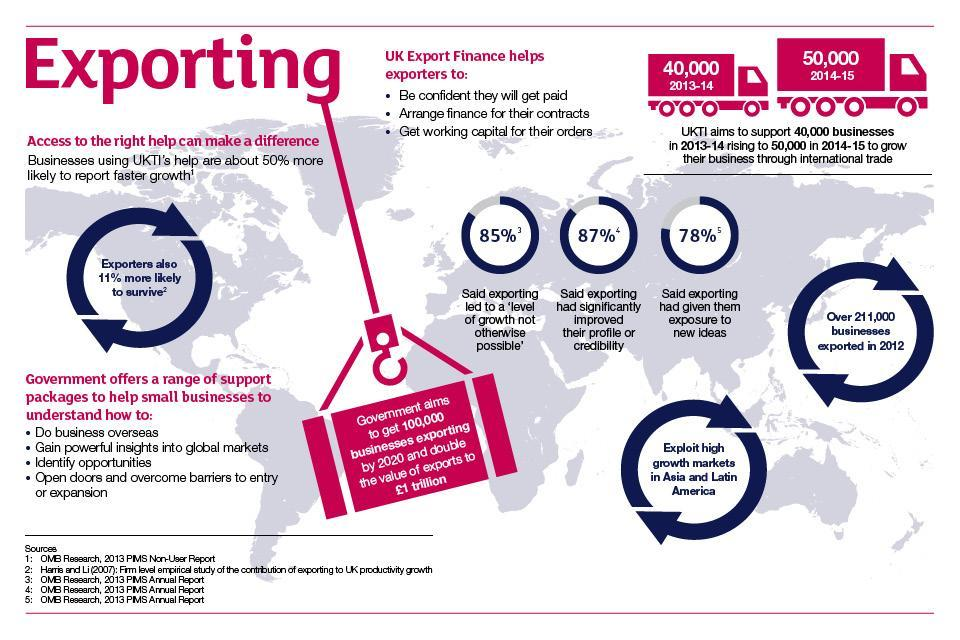By what number did businesses rise from 2013-14 to 2014-15?
Answer the question with a short phrase. 10,000 